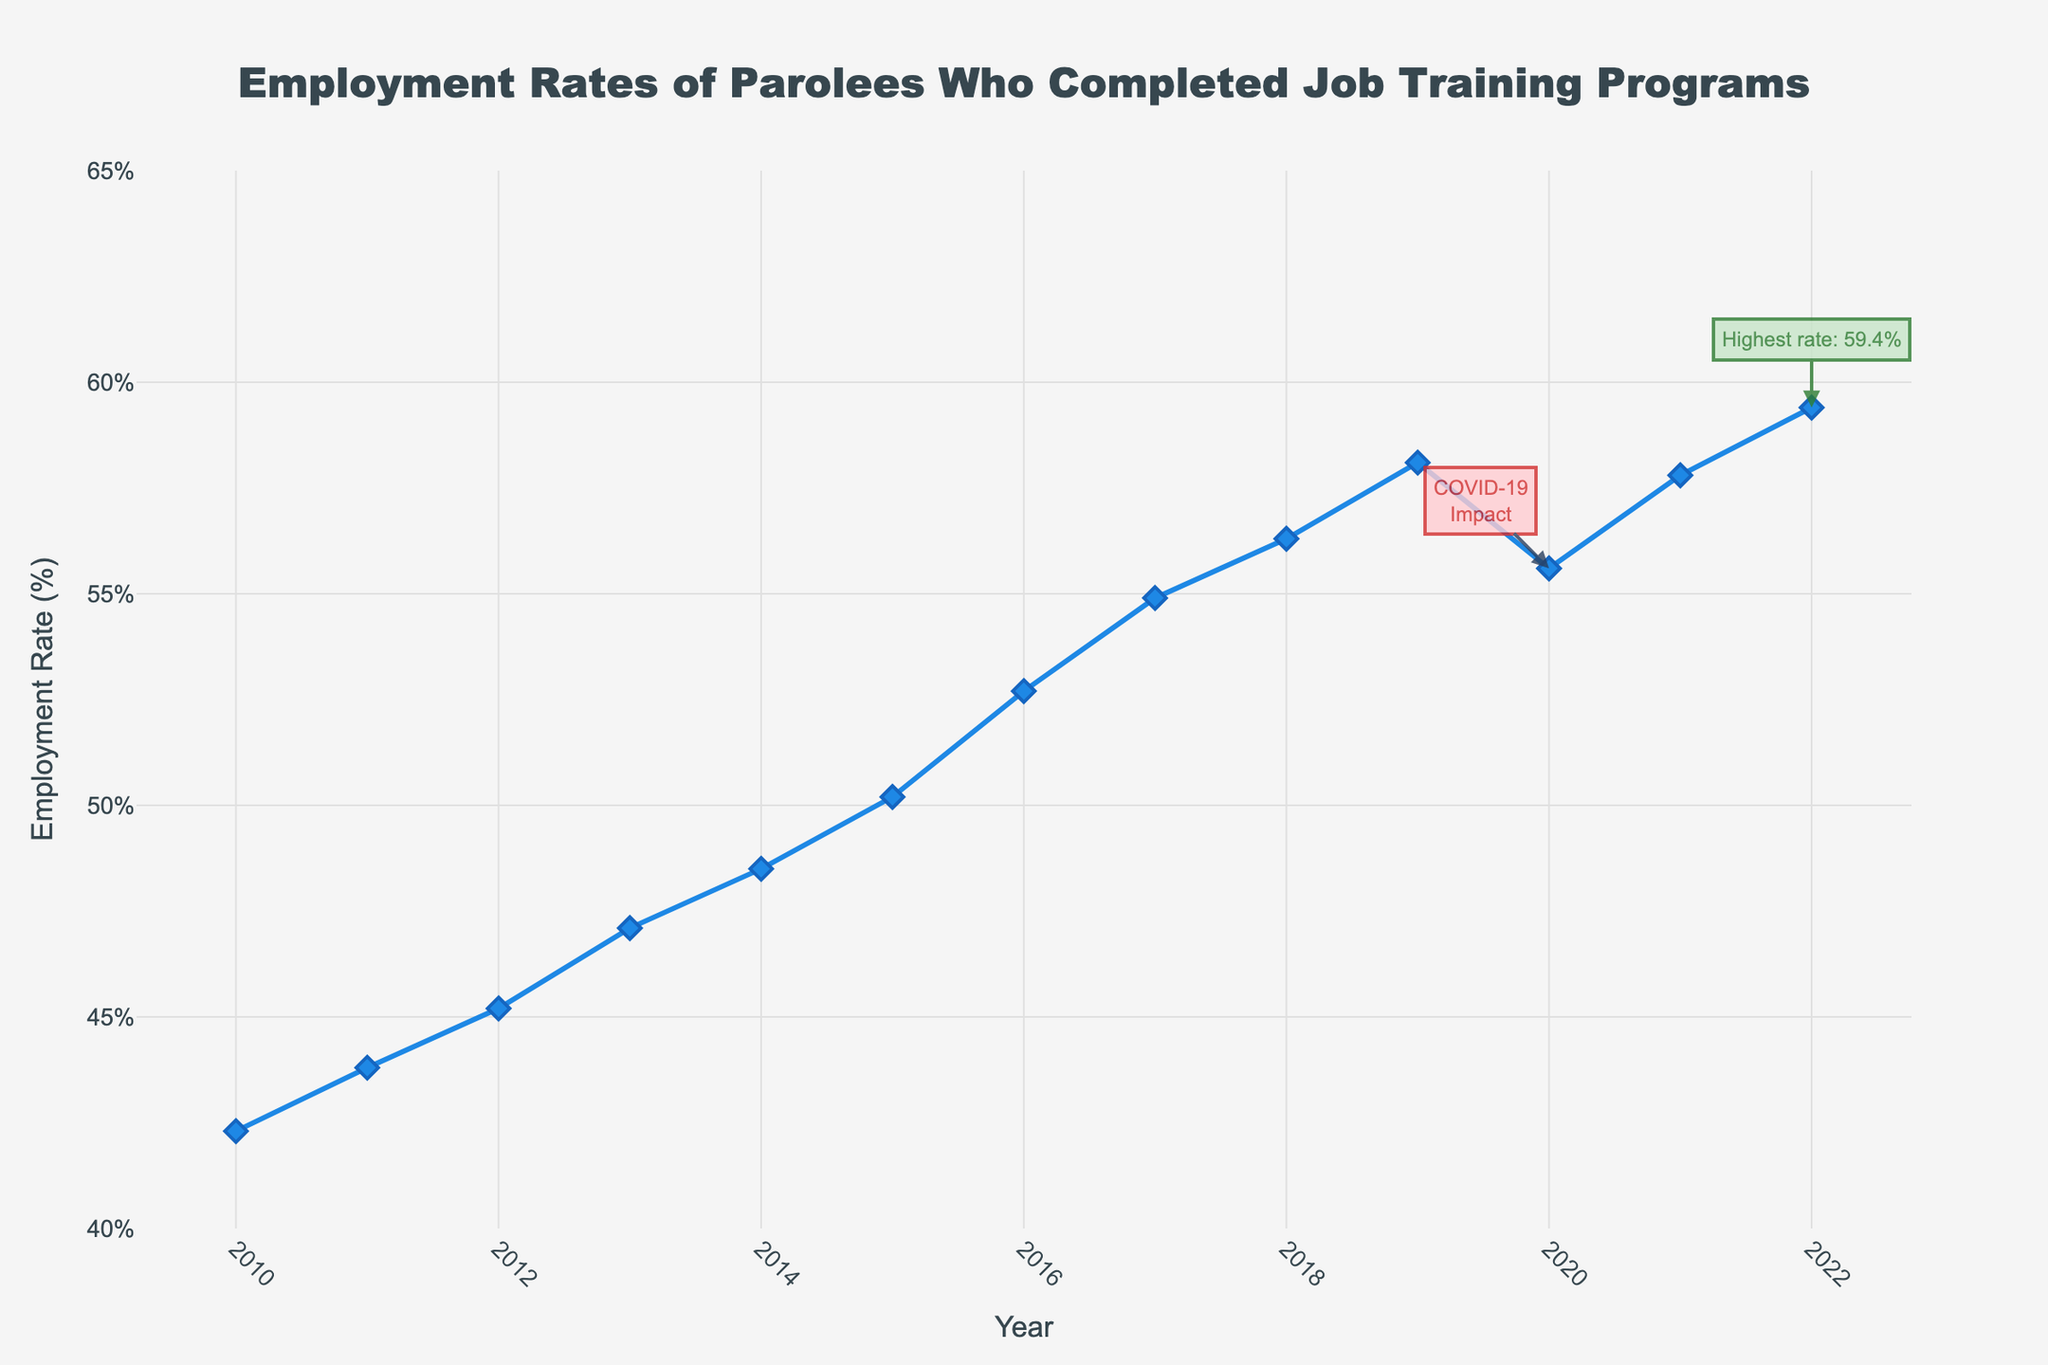What is the overall trend of employment rates of parolees from 2010 to 2022? The trend seems to be increasing overall, despite a slight dip in 2020. The employment rate starts at 42.3% in 2010 and reaches its highest value of 59.4% in 2022.
Answer: Increasing In which year did the employment rate of parolees reach its highest point? The highest point is indicated by an annotation on the chart. It shows that the employment rate reached its highest point in 2022 at 59.4%.
Answer: 2022 What was the employment rate in 2020 and why might it have decreased compared to 2019? The employment rate in 2020 was 55.6%. The decrease compared to 2019 (which was 58.1%) might be due to the impact of COVID-19, as highlighted by the annotation on the chart.
Answer: 55.6% How many times did the employment rate of parolees increase between consecutive years? By examining the plotted line, we can see that the employment rate increased between consecutive years 11 times out of 12. The only exception is between 2019 and 2020.
Answer: 11 times What is the average employment rate from 2010 to 2022? The average is calculated by summing up all the employment rates from 2010 to 2022 and then dividing by the number of years (13). The sum is 700.9, so the average is 700.9 / 13 ≈ 53.92%.
Answer: 53.92% By how many percentage points did the employment rate change from 2010 to 2022? The change is found by subtracting the employment rate in 2010 (42.3%) from that in 2022 (59.4%). So, the change is 59.4% - 42.3% = 17.1 percentage points.
Answer: 17.1 percentage points Which year had the smallest increase in employment rate compared to its previous year? By comparing the differences year-over-year, 2020 had the smallest increase (in fact, it had a decrease) of -2.5%. For increases, 2013 had the smallest increase, where the increase was 1.9 percentage points from 47.1% in 2013 to 48.5% in 2014.
Answer: 2020 What is the difference in employment rate between the year with the highest rate and the year with the lowest rate? The highest rate is 59.4% in 2022 and the lowest rate is 42.3% in 2010. The difference is 59.4% - 42.3% = 17.1 percentage points.
Answer: 17.1 percentage points From the visual annotations and the color of the arrows, what important events are highlighted on the chart? Two events are highlighted; in 2020, the text "COVID-19 Impact" is annotated in red, indicating a decrease, and in 2022, the text "Highest rate: 59.4%" is annotated in green, indicating the highest employment rate reached.
Answer: COVID-19 Impact and Highest rate During which period did the employment rate of parolees grow the most rapidly? By comparing the slopes of the line segments between the points, the period between 2015 and 2017 shows the most rapid growth from 50.2% to 54.9%, an increase of 4.7 percentage points over 2 years.
Answer: 2015 to 2017 